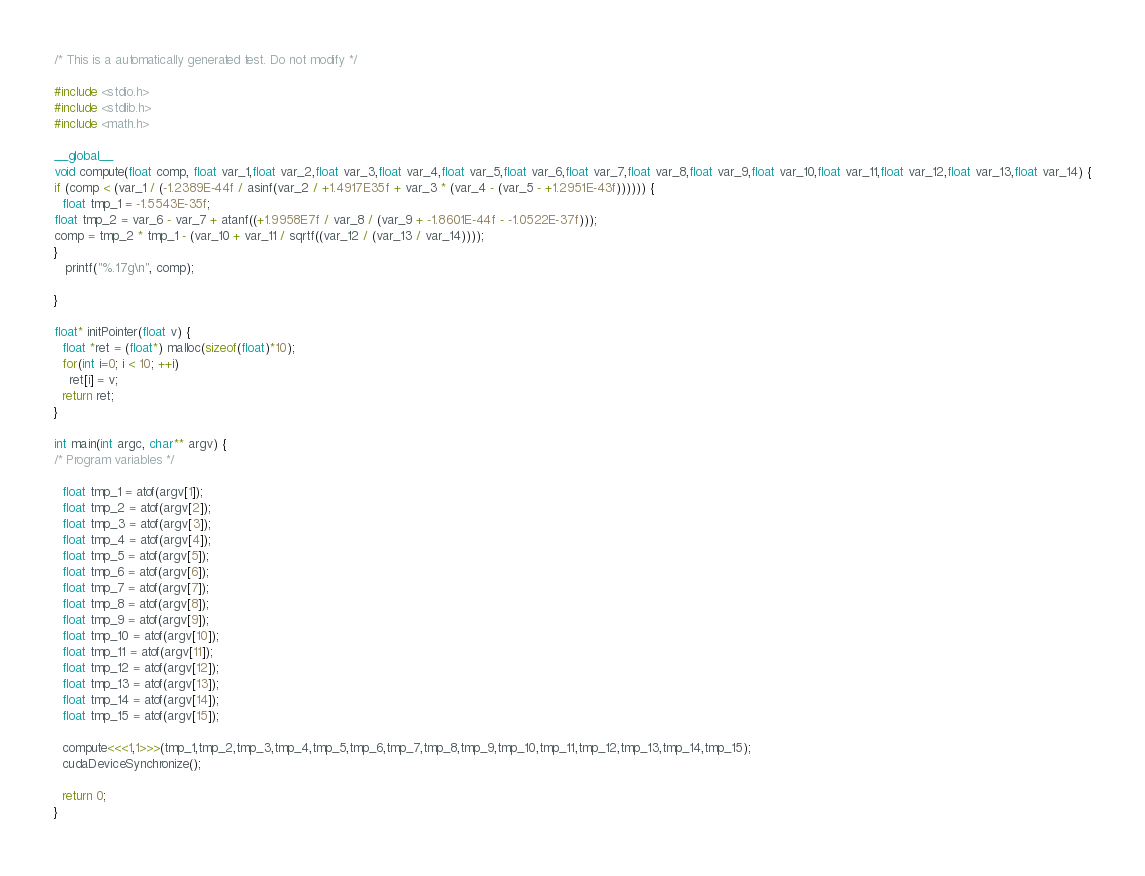<code> <loc_0><loc_0><loc_500><loc_500><_Cuda_>
/* This is a automatically generated test. Do not modify */

#include <stdio.h>
#include <stdlib.h>
#include <math.h>

__global__
void compute(float comp, float var_1,float var_2,float var_3,float var_4,float var_5,float var_6,float var_7,float var_8,float var_9,float var_10,float var_11,float var_12,float var_13,float var_14) {
if (comp < (var_1 / (-1.2389E-44f / asinf(var_2 / +1.4917E35f + var_3 * (var_4 - (var_5 - +1.2951E-43f)))))) {
  float tmp_1 = -1.5543E-35f;
float tmp_2 = var_6 - var_7 + atanf((+1.9958E7f / var_8 / (var_9 + -1.8601E-44f - -1.0522E-37f)));
comp = tmp_2 * tmp_1 - (var_10 + var_11 / sqrtf((var_12 / (var_13 / var_14))));
}
   printf("%.17g\n", comp);

}

float* initPointer(float v) {
  float *ret = (float*) malloc(sizeof(float)*10);
  for(int i=0; i < 10; ++i)
    ret[i] = v;
  return ret;
}

int main(int argc, char** argv) {
/* Program variables */

  float tmp_1 = atof(argv[1]);
  float tmp_2 = atof(argv[2]);
  float tmp_3 = atof(argv[3]);
  float tmp_4 = atof(argv[4]);
  float tmp_5 = atof(argv[5]);
  float tmp_6 = atof(argv[6]);
  float tmp_7 = atof(argv[7]);
  float tmp_8 = atof(argv[8]);
  float tmp_9 = atof(argv[9]);
  float tmp_10 = atof(argv[10]);
  float tmp_11 = atof(argv[11]);
  float tmp_12 = atof(argv[12]);
  float tmp_13 = atof(argv[13]);
  float tmp_14 = atof(argv[14]);
  float tmp_15 = atof(argv[15]);

  compute<<<1,1>>>(tmp_1,tmp_2,tmp_3,tmp_4,tmp_5,tmp_6,tmp_7,tmp_8,tmp_9,tmp_10,tmp_11,tmp_12,tmp_13,tmp_14,tmp_15);
  cudaDeviceSynchronize();

  return 0;
}
</code> 